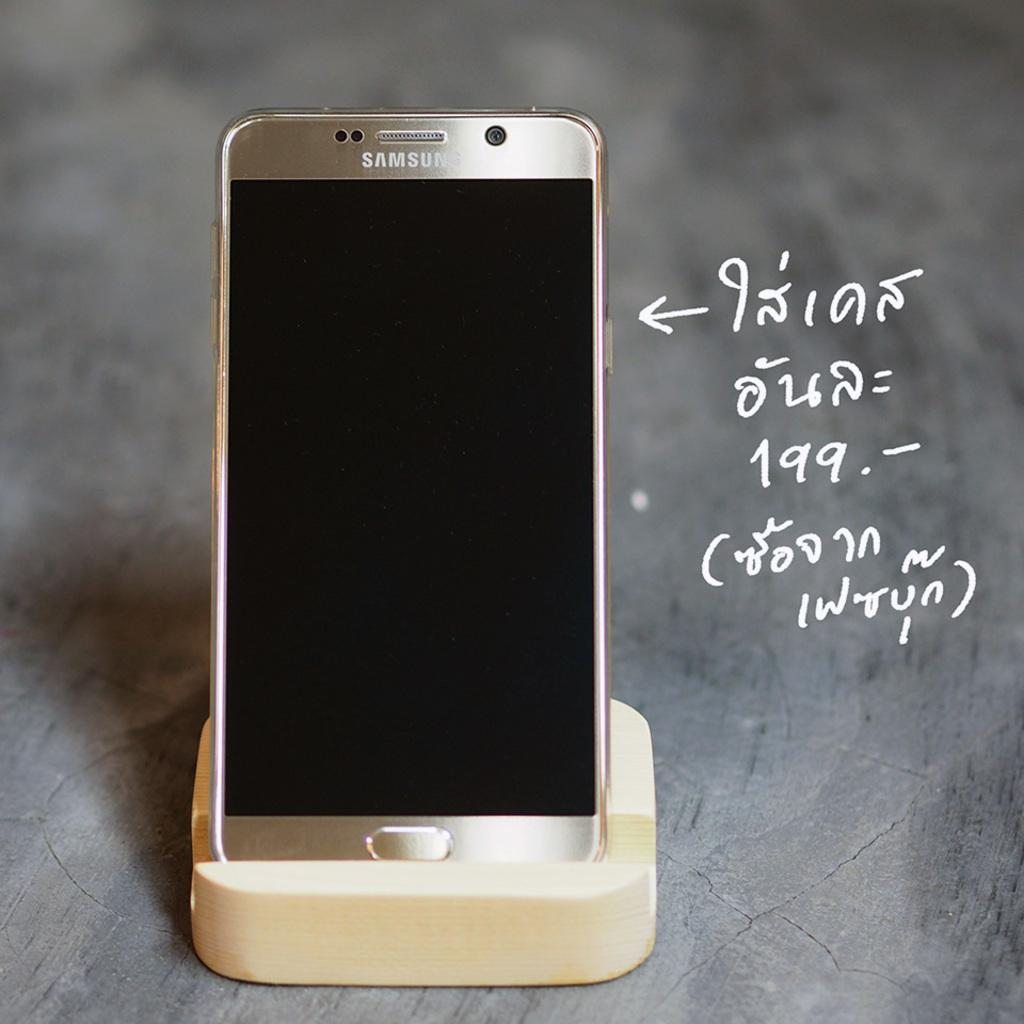Provide a one-sentence caption for the provided image. A Samsung phone sits upright on a stand, next to some white writing. 